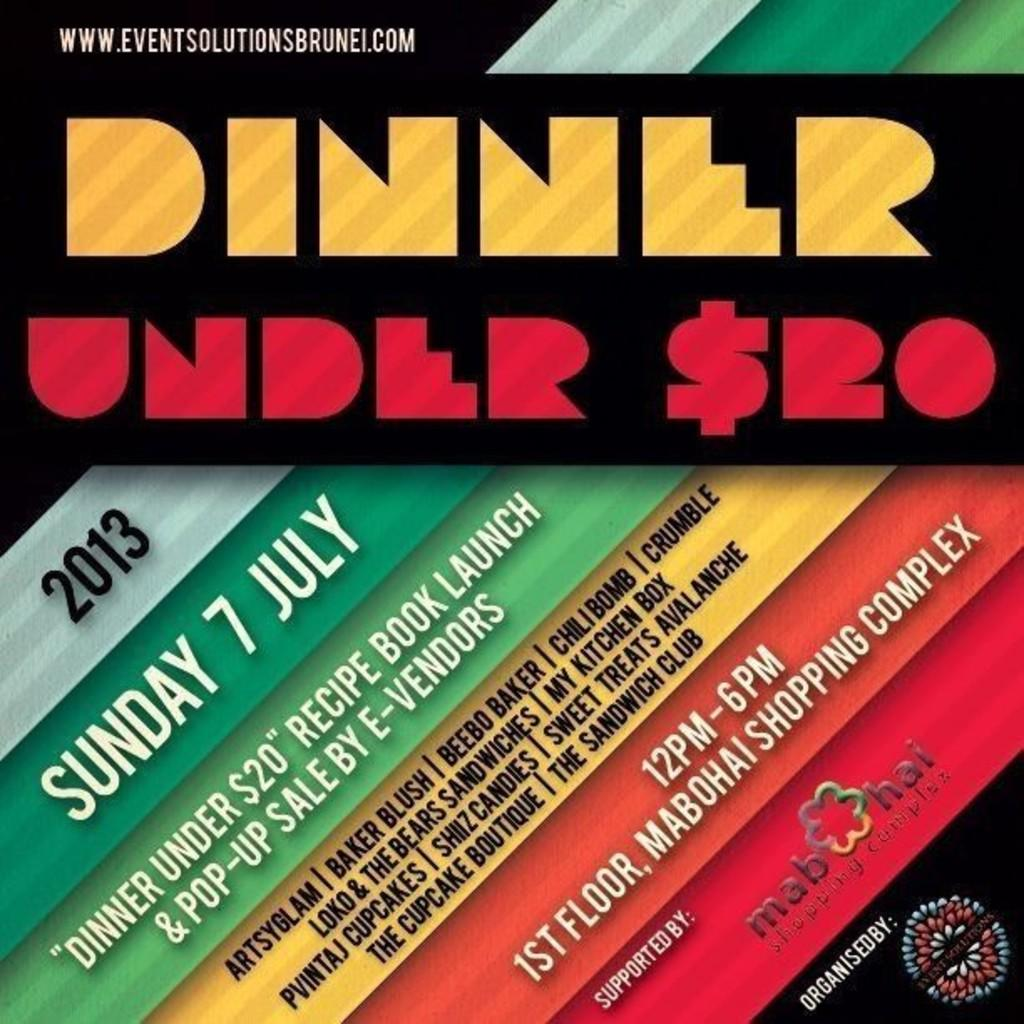<image>
Render a clear and concise summary of the photo. A book titled Dinner Under $20 in yellow and red. 